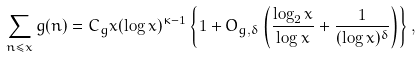Convert formula to latex. <formula><loc_0><loc_0><loc_500><loc_500>\sum _ { n \leq x } g ( n ) = C _ { g } x ( \log x ) ^ { \kappa - 1 } \left \{ 1 + O _ { g , \delta } \left ( \frac { \log _ { 2 } x } { \log x } + \frac { 1 } { ( \log x ) ^ { \delta } } \right ) \right \} ,</formula> 